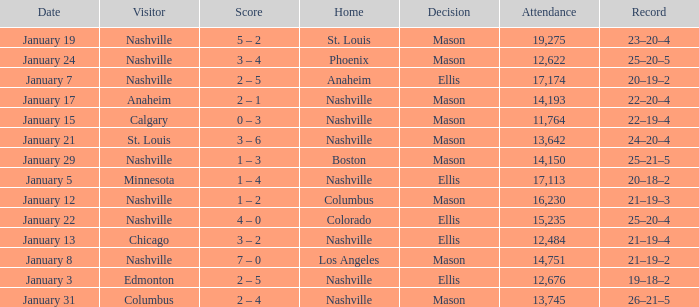On January 29, who had the decision of Mason? Nashville. 